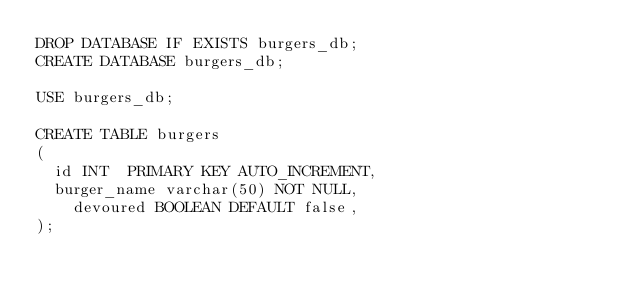<code> <loc_0><loc_0><loc_500><loc_500><_SQL_>DROP DATABASE IF EXISTS burgers_db;
CREATE DATABASE burgers_db;

USE burgers_db;

CREATE TABLE burgers
(
	id INT  PRIMARY KEY AUTO_INCREMENT,
	burger_name varchar(50) NOT NULL,
    devoured BOOLEAN DEFAULT false,
);</code> 